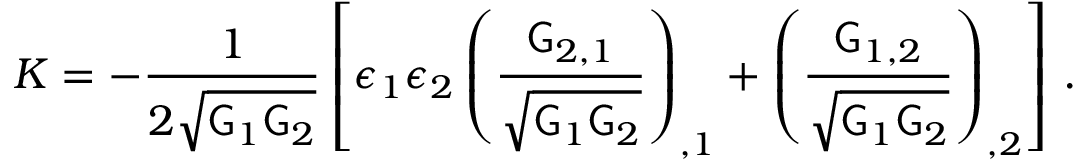<formula> <loc_0><loc_0><loc_500><loc_500>K = - \frac { 1 } { 2 \sqrt { G _ { 1 } G _ { 2 } } } \left [ \epsilon _ { 1 } \epsilon _ { 2 } \left ( \frac { G _ { 2 , 1 } } { \sqrt { G _ { 1 } G _ { 2 } } } \right ) _ { , 1 } + \left ( \frac { G _ { 1 , 2 } } { \sqrt { G _ { 1 } G _ { 2 } } } \right ) _ { , 2 } \right ] \, .</formula> 